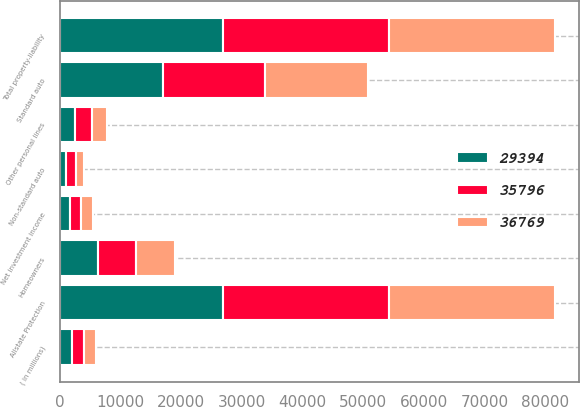Convert chart to OTSL. <chart><loc_0><loc_0><loc_500><loc_500><stacked_bar_chart><ecel><fcel>( in millions)<fcel>Standard auto<fcel>Non-standard auto<fcel>Homeowners<fcel>Other personal lines<fcel>Allstate Protection<fcel>Total property-liability<fcel>Net investment income<nl><fcel>29394<fcel>2008<fcel>17048<fcel>1100<fcel>6261<fcel>2558<fcel>26967<fcel>26967<fcel>1674<nl><fcel>36769<fcel>2007<fcel>17079<fcel>1308<fcel>6283<fcel>2562<fcel>27232<fcel>27233<fcel>1972<nl><fcel>35796<fcel>2006<fcel>16750<fcel>1535<fcel>6383<fcel>2698<fcel>27366<fcel>27369<fcel>1854<nl></chart> 